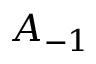Convert formula to latex. <formula><loc_0><loc_0><loc_500><loc_500>A _ { - 1 }</formula> 